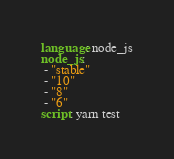Convert code to text. <code><loc_0><loc_0><loc_500><loc_500><_YAML_>language: node_js
node_js:
 - "stable"
 - "10"
 - "8"
 - "6"
script: yarn test
</code> 